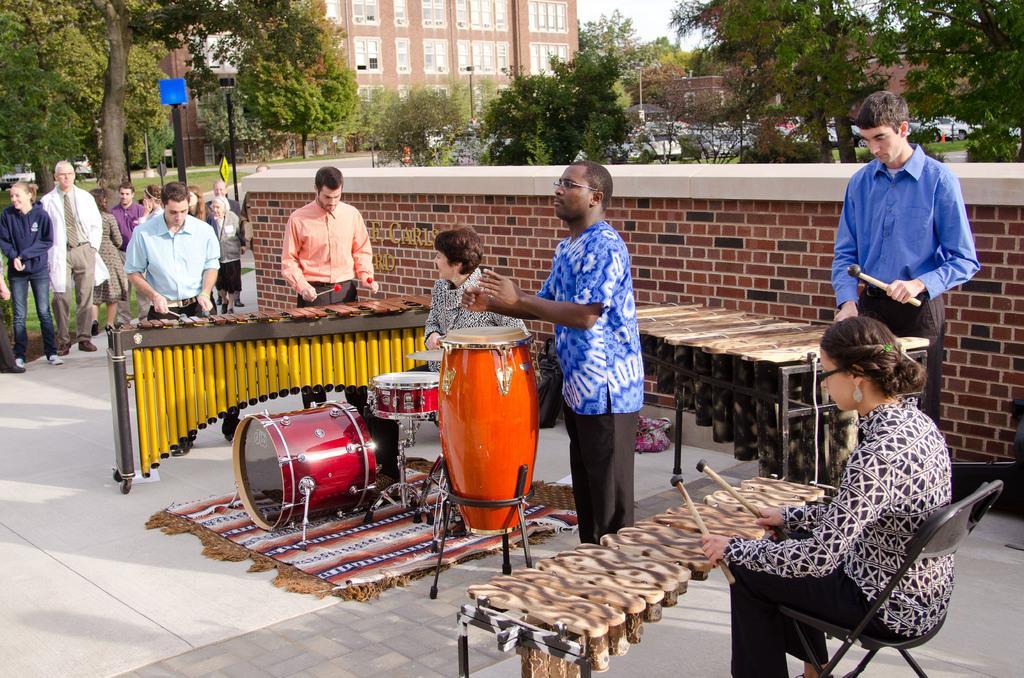In one or two sentences, can you explain what this image depicts? On the background we can see sky, a huge building, trees and few vehicles parked here. Here we can see a wall with bricks. We can see persons standing, sitting and playing musical instruments. This is a board. We can see persons standing here. 